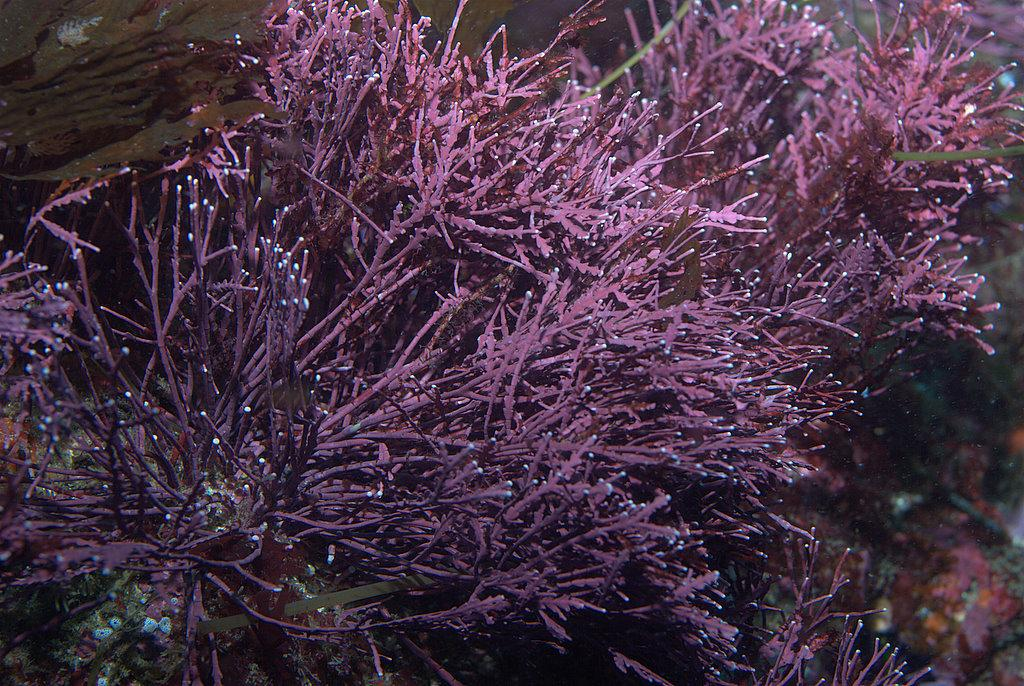What type of living organisms can be seen in the image? Plants can be seen in the image. What colors are the plants in the image? The plants are pink and green in color. What can be seen in the background of the image? There are other objects in the background of the image. What colors are the background objects in the image? The background objects are pink, orange, and white in color. What thought process does the plant go through when deciding to stretch in the image? Plants do not have a thought process or the ability to stretch like animals or humans. 